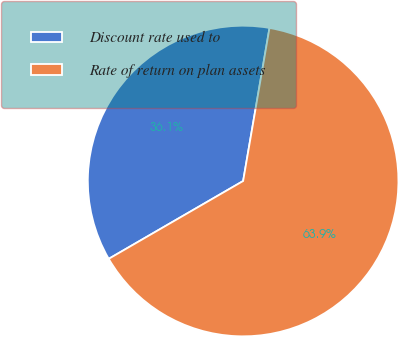Convert chart. <chart><loc_0><loc_0><loc_500><loc_500><pie_chart><fcel>Discount rate used to<fcel>Rate of return on plan assets<nl><fcel>36.07%<fcel>63.93%<nl></chart> 